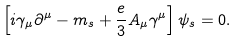Convert formula to latex. <formula><loc_0><loc_0><loc_500><loc_500>\left [ i \gamma _ { \mu } \partial ^ { \mu } - m _ { s } + \frac { e } { 3 } A _ { \mu } \gamma ^ { \mu } \right ] \psi _ { s } = 0 .</formula> 